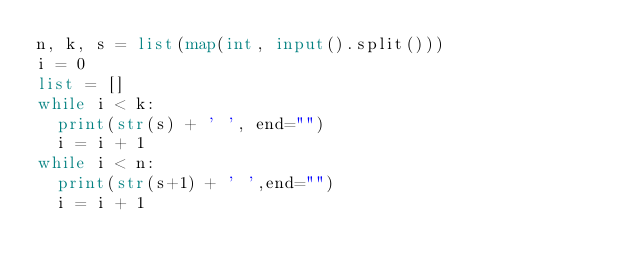Convert code to text. <code><loc_0><loc_0><loc_500><loc_500><_Python_>n, k, s = list(map(int, input().split()))
i = 0
list = []
while i < k:
  print(str(s) + ' ', end="")
  i = i + 1
while i < n:
  print(str(s+1) + ' ',end="")
  i = i + 1

</code> 